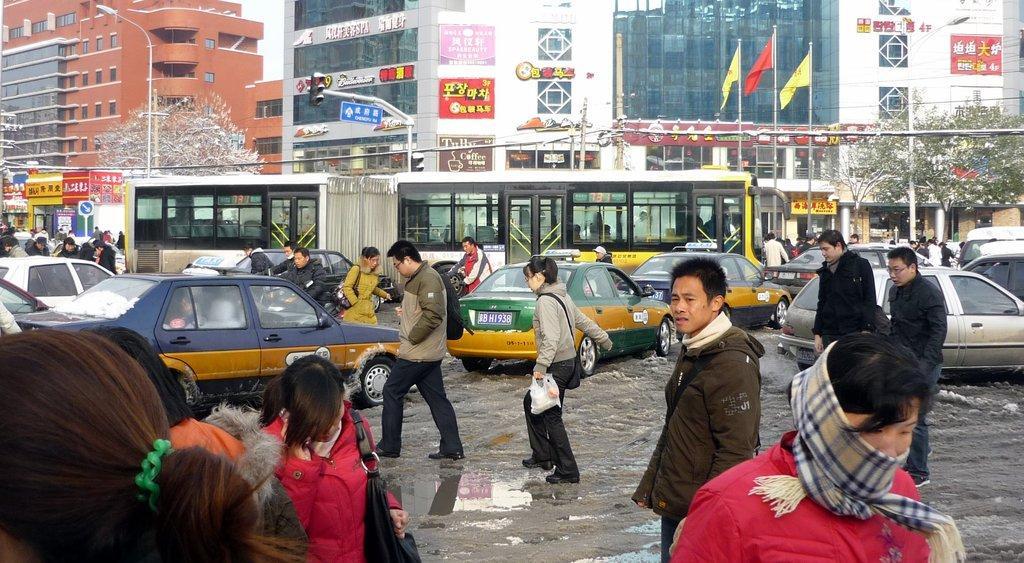How would you summarize this image in a sentence or two? In this image we can see some persons walking and some are crossing the road, we can see some vehicles moving on road and in the background of the image there are some trees, traffic signals, electric poles, some buildings and we can see some flags. 